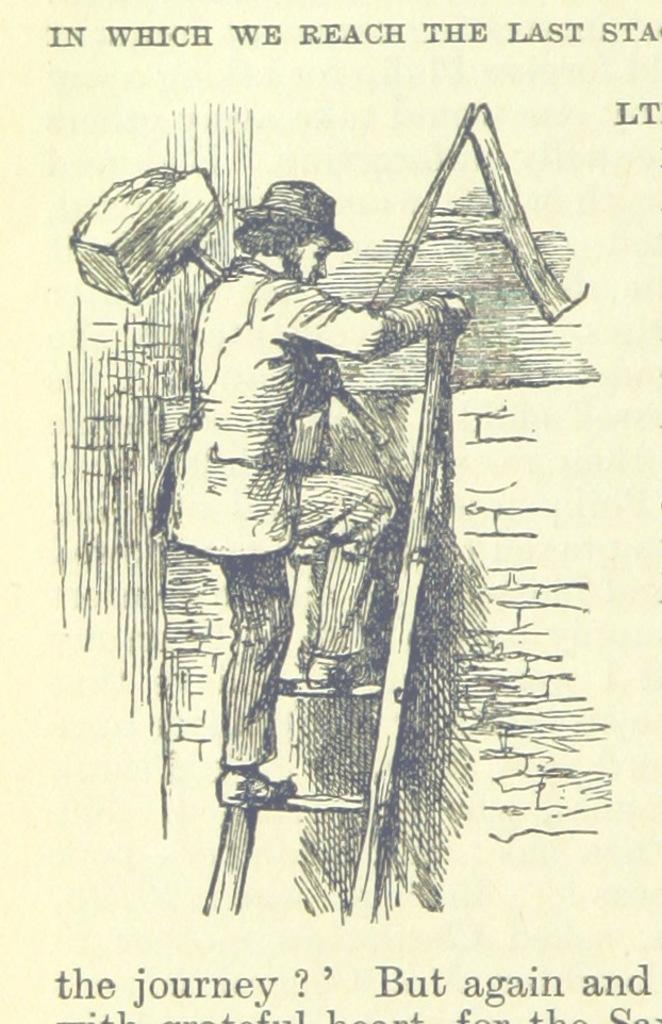What is on the paper that is visible in the image? There is a paper with words in the image, and it also contains a picture. What is happening in the picture on the paper? The picture depicts a person holding an object and climbing a ladder. What type of tree can be seen in the image? There is no tree present in the image; the picture on the paper depicts a person climbing a ladder. 